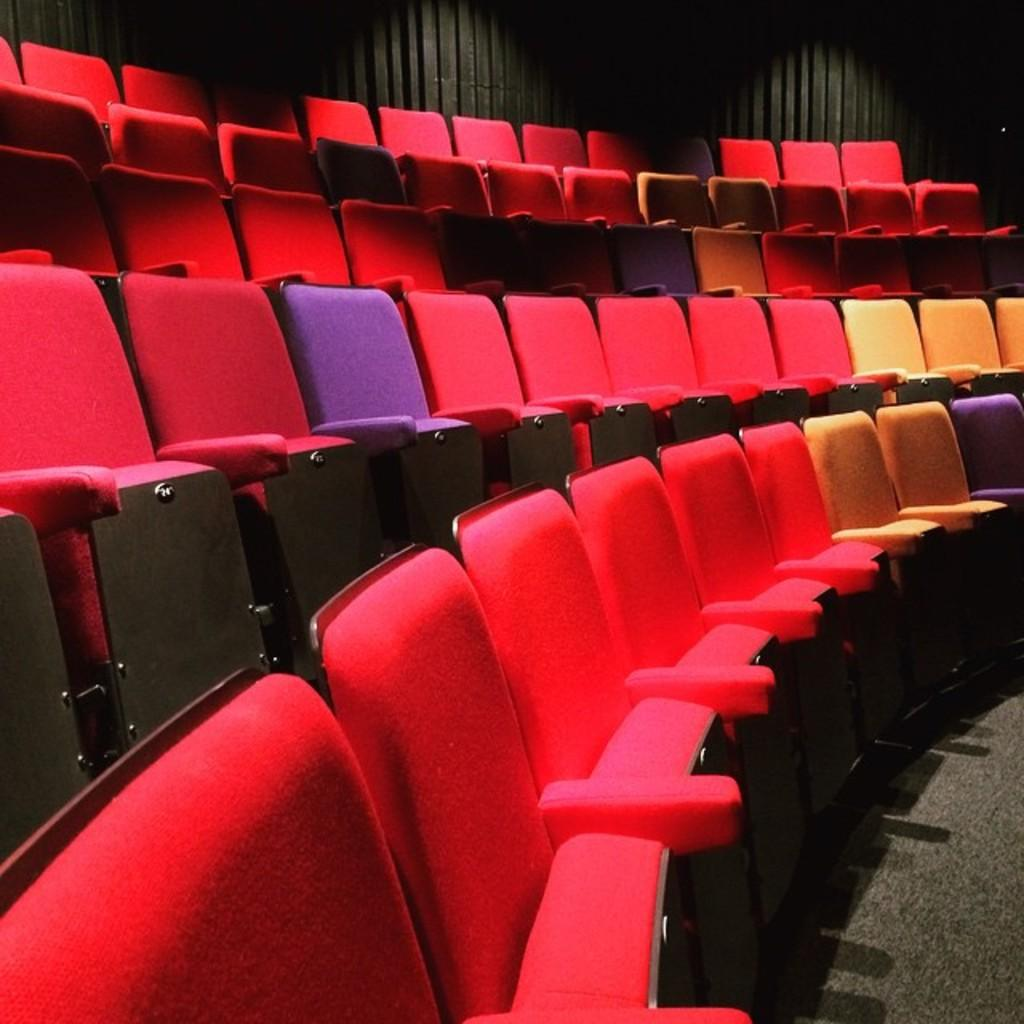What type of objects are present in the image? There are seats in the image. How many seats can be seen in the image? The number of seats is not specified, but there are seats present. What might the seats be used for? The seats could be used for sitting or resting. What type of gold can be seen on the lizards in the image? There are no lizards or gold present in the image; it only features seats. 